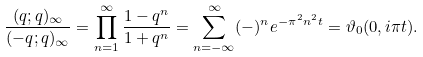<formula> <loc_0><loc_0><loc_500><loc_500>\frac { ( q ; q ) _ { \infty } } { ( - q ; q ) _ { \infty } } = \prod _ { n = 1 } ^ { \infty } \frac { 1 - q ^ { n } } { 1 + q ^ { n } } = \sum _ { n = - \infty } ^ { \infty } ( - ) ^ { n } e ^ { - \pi ^ { 2 } n ^ { 2 } t } = \vartheta _ { 0 } ( 0 , i \pi t ) .</formula> 